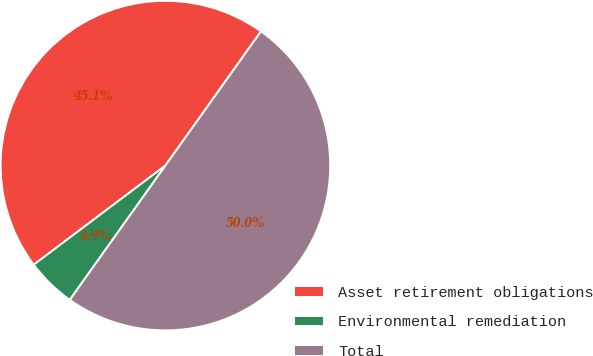Convert chart. <chart><loc_0><loc_0><loc_500><loc_500><pie_chart><fcel>Asset retirement obligations<fcel>Environmental remediation<fcel>Total<nl><fcel>45.12%<fcel>4.88%<fcel>50.0%<nl></chart> 